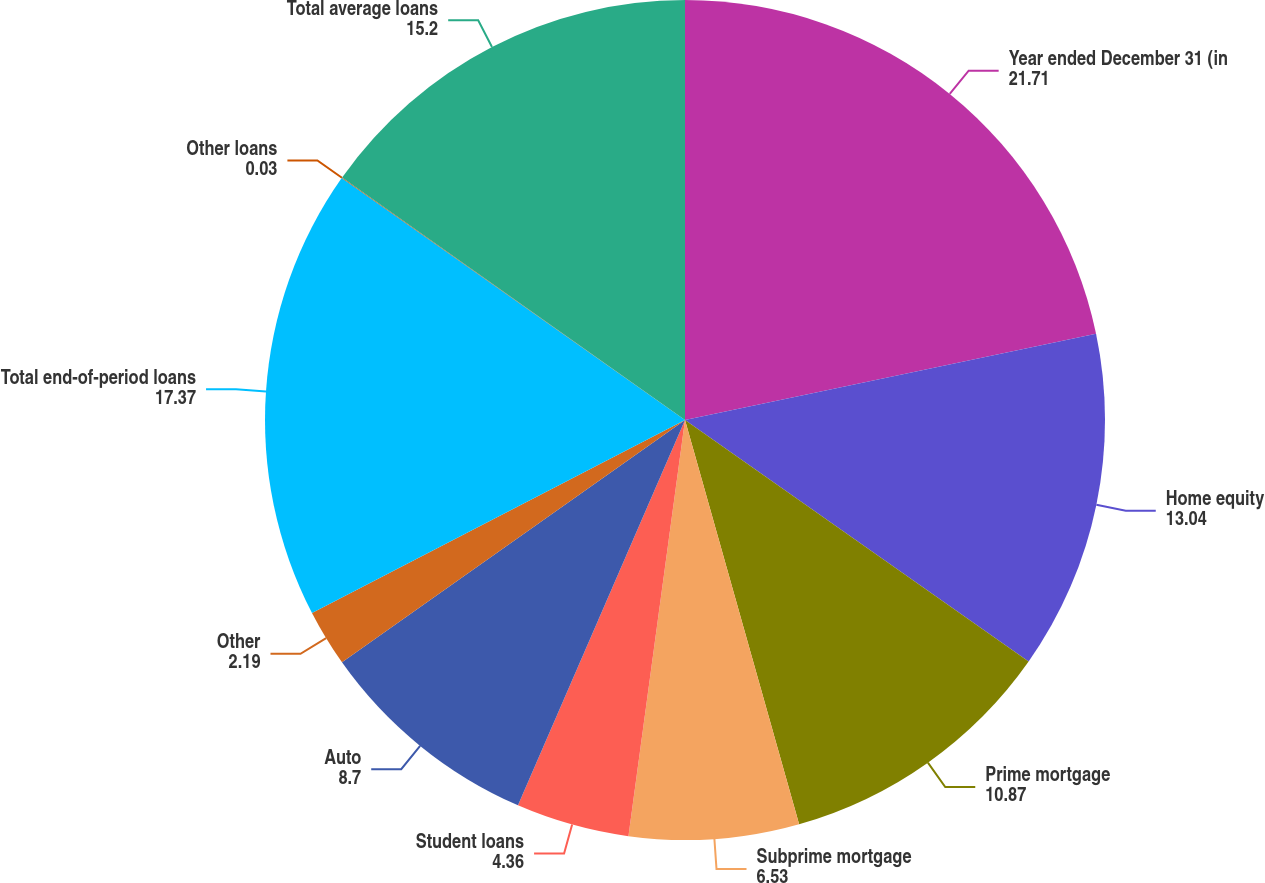<chart> <loc_0><loc_0><loc_500><loc_500><pie_chart><fcel>Year ended December 31 (in<fcel>Home equity<fcel>Prime mortgage<fcel>Subprime mortgage<fcel>Student loans<fcel>Auto<fcel>Other<fcel>Total end-of-period loans<fcel>Other loans<fcel>Total average loans<nl><fcel>21.71%<fcel>13.04%<fcel>10.87%<fcel>6.53%<fcel>4.36%<fcel>8.7%<fcel>2.19%<fcel>17.37%<fcel>0.03%<fcel>15.2%<nl></chart> 